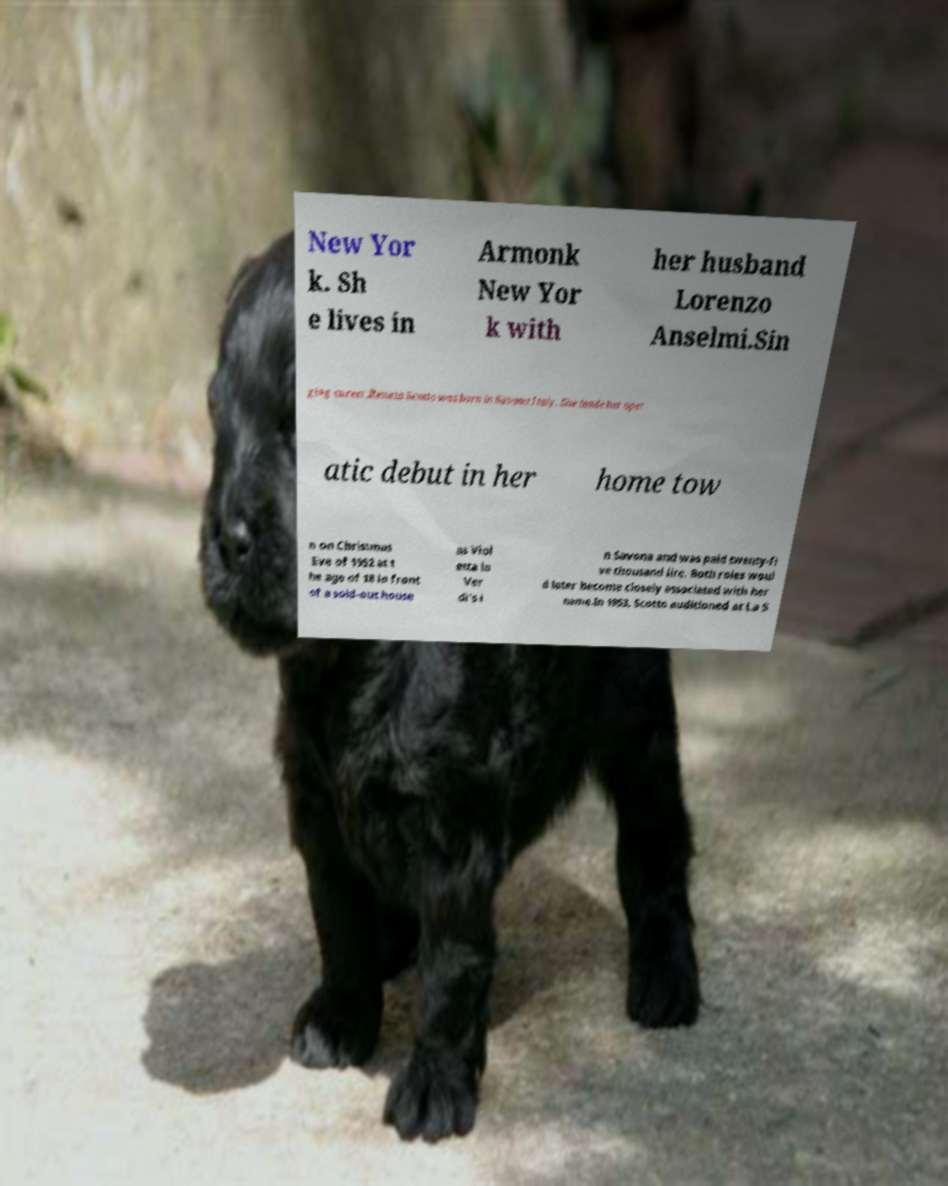Please read and relay the text visible in this image. What does it say? New Yor k. Sh e lives in Armonk New Yor k with her husband Lorenzo Anselmi.Sin ging career.Renata Scotto was born in Savona Italy. She made her oper atic debut in her home tow n on Christmas Eve of 1952 at t he age of 18 in front of a sold-out house as Viol etta in Ver di's i n Savona and was paid twenty-fi ve thousand lire. Both roles woul d later become closely associated with her name.In 1953, Scotto auditioned at La S 